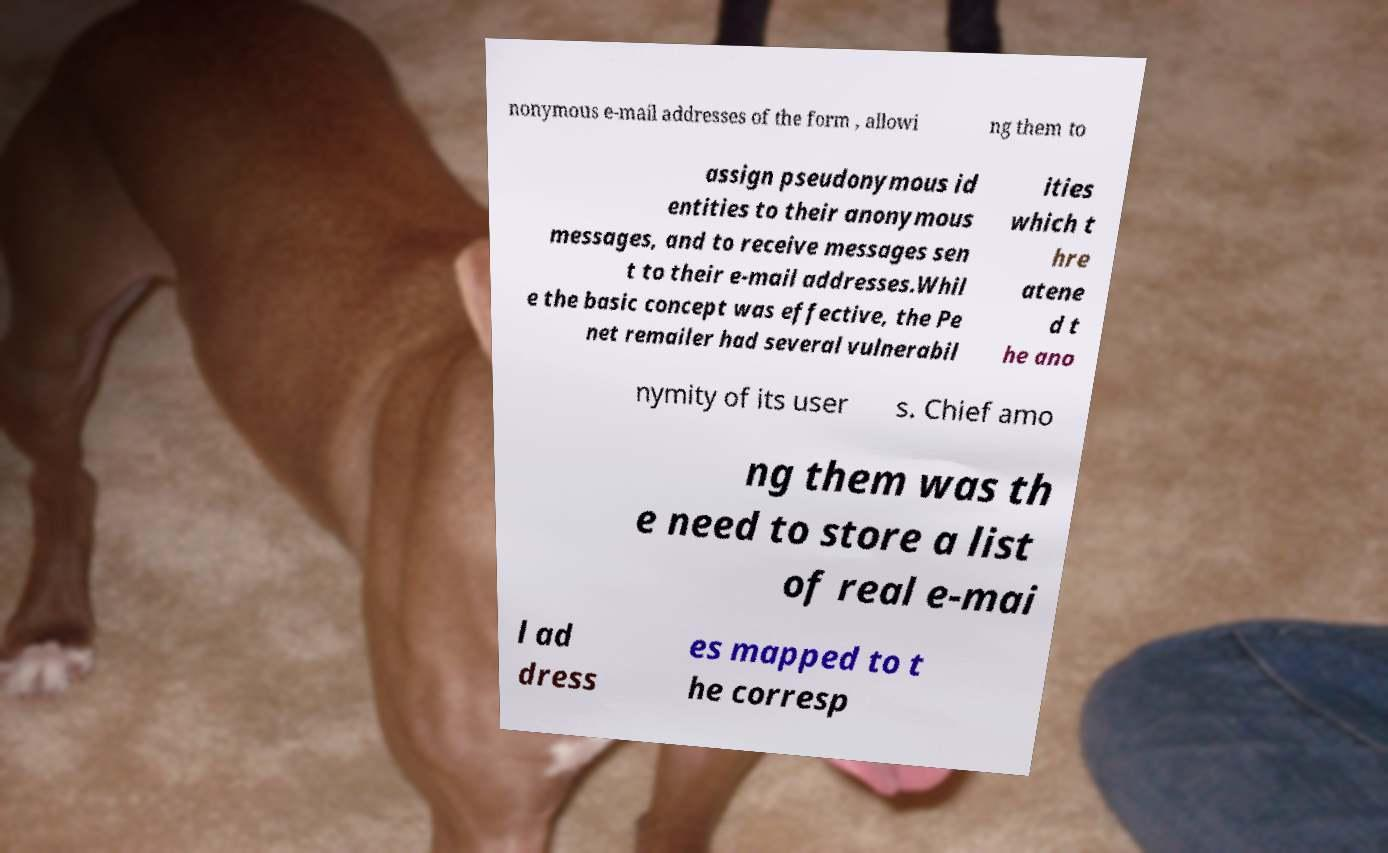I need the written content from this picture converted into text. Can you do that? nonymous e-mail addresses of the form , allowi ng them to assign pseudonymous id entities to their anonymous messages, and to receive messages sen t to their e-mail addresses.Whil e the basic concept was effective, the Pe net remailer had several vulnerabil ities which t hre atene d t he ano nymity of its user s. Chief amo ng them was th e need to store a list of real e-mai l ad dress es mapped to t he corresp 